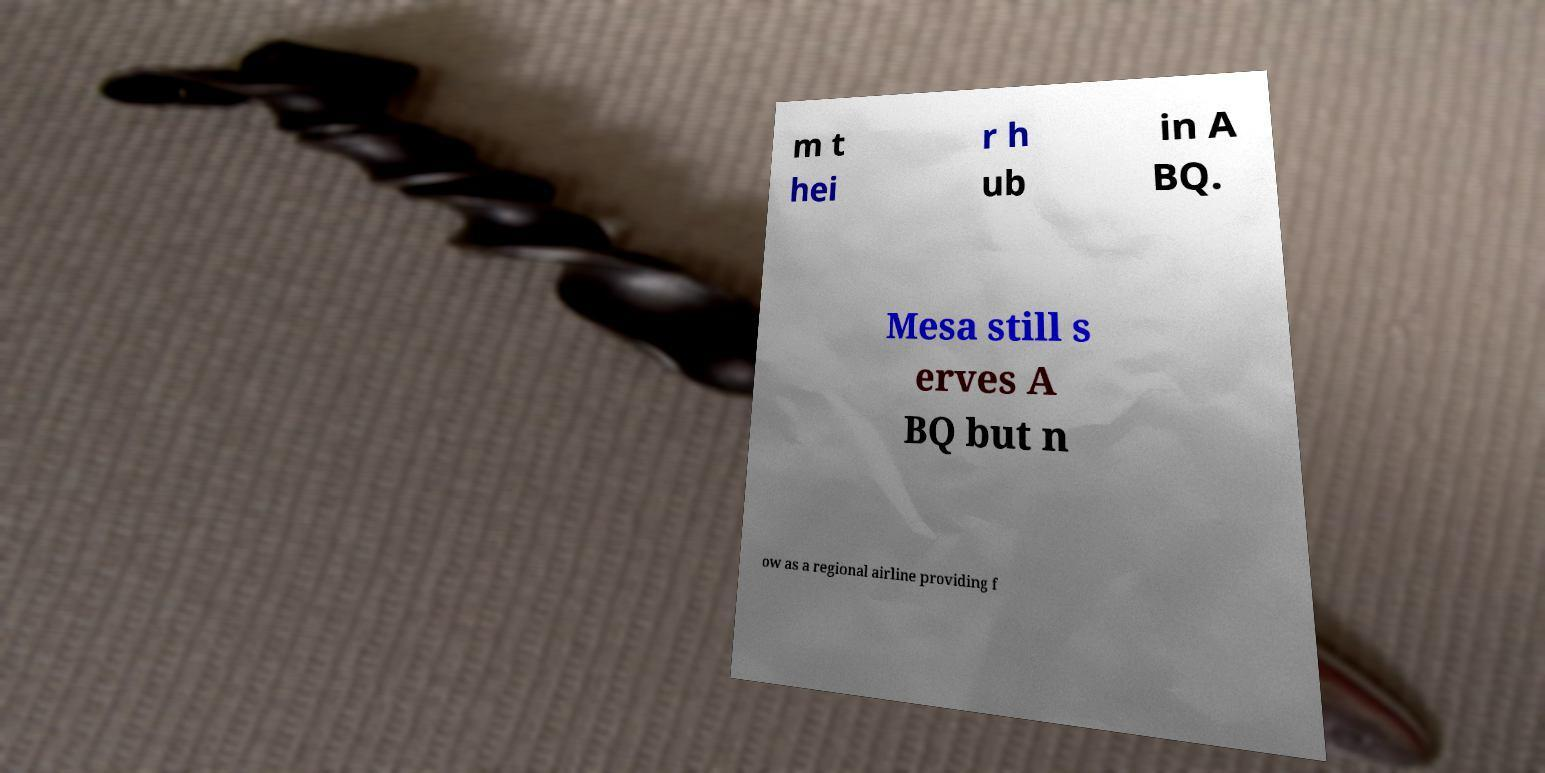Could you extract and type out the text from this image? m t hei r h ub in A BQ. Mesa still s erves A BQ but n ow as a regional airline providing f 